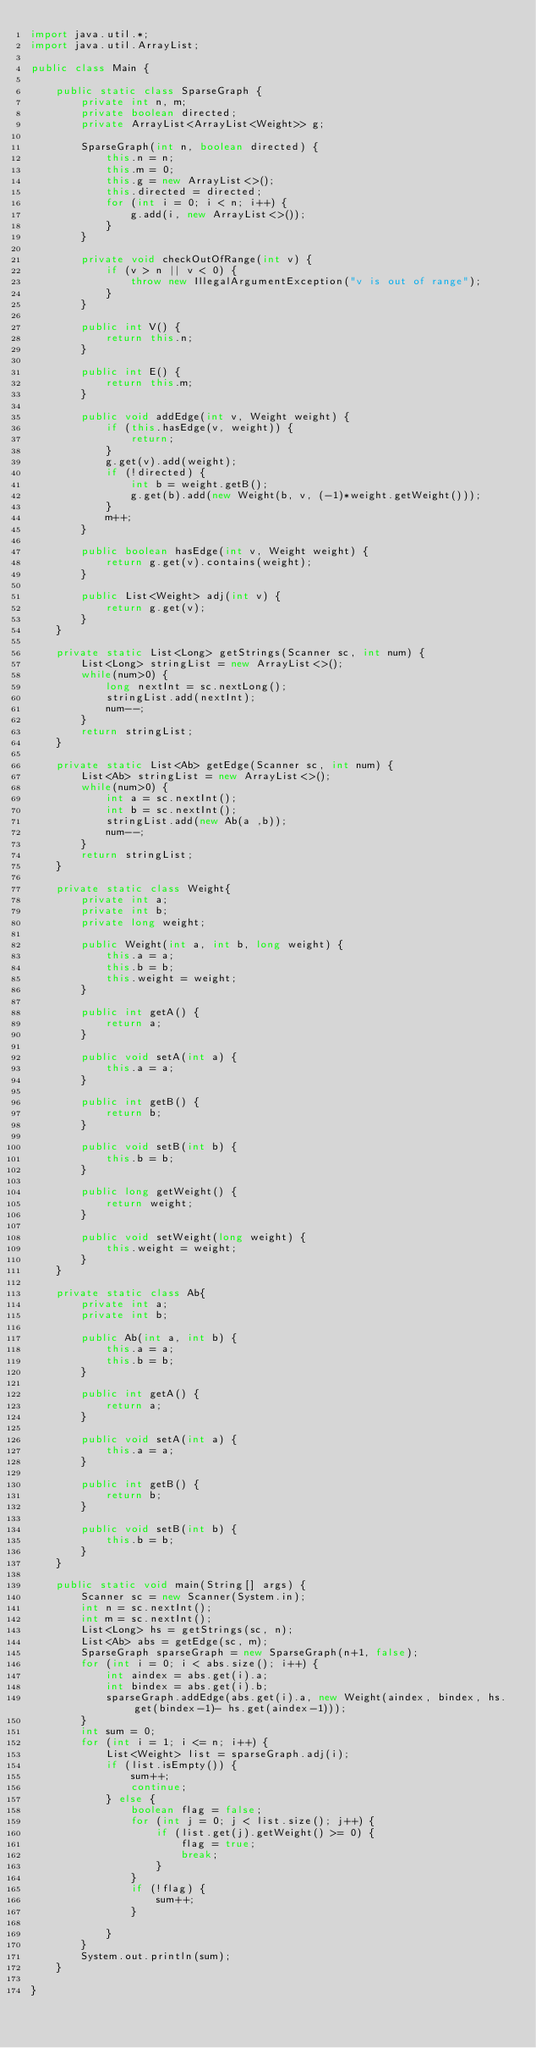<code> <loc_0><loc_0><loc_500><loc_500><_Java_>import java.util.*;
import java.util.ArrayList;

public class Main {

	public static class SparseGraph {
		private int n, m;
		private boolean directed;
		private ArrayList<ArrayList<Weight>> g;

		SparseGraph(int n, boolean directed) {
			this.n = n;
			this.m = 0;
			this.g = new ArrayList<>();
			this.directed = directed;
			for (int i = 0; i < n; i++) {
				g.add(i, new ArrayList<>());
			}
		}

		private void checkOutOfRange(int v) {
			if (v > n || v < 0) {
				throw new IllegalArgumentException("v is out of range");
			}
		}

		public int V() {
			return this.n;
		}

		public int E() {
			return this.m;
		}

		public void addEdge(int v, Weight weight) {
			if (this.hasEdge(v, weight)) {
				return;
			}
			g.get(v).add(weight);
			if (!directed) {
				int b = weight.getB();
				g.get(b).add(new Weight(b, v, (-1)*weight.getWeight()));
			}
			m++;
		}

		public boolean hasEdge(int v, Weight weight) {
			return g.get(v).contains(weight);
		}

		public List<Weight> adj(int v) {
			return g.get(v);
		}
	}

	private static List<Long> getStrings(Scanner sc, int num) {
		List<Long> stringList = new ArrayList<>();
		while(num>0) {
			long nextInt = sc.nextLong();
			stringList.add(nextInt);
			num--;
		}
		return stringList;
	}

	private static List<Ab> getEdge(Scanner sc, int num) {
		List<Ab> stringList = new ArrayList<>();
		while(num>0) {
			int a = sc.nextInt();
			int b = sc.nextInt();
			stringList.add(new Ab(a ,b));
			num--;
		}
		return stringList;
	}

	private static class Weight{
		private int a;
		private int b;
		private long weight;

		public Weight(int a, int b, long weight) {
			this.a = a;
			this.b = b;
			this.weight = weight;
		}

		public int getA() {
			return a;
		}

		public void setA(int a) {
			this.a = a;
		}

		public int getB() {
			return b;
		}

		public void setB(int b) {
			this.b = b;
		}

		public long getWeight() {
			return weight;
		}

		public void setWeight(long weight) {
			this.weight = weight;
		}
	}

	private static class Ab{
		private int a;
		private int b;

		public Ab(int a, int b) {
			this.a = a;
			this.b = b;
		}

		public int getA() {
			return a;
		}

		public void setA(int a) {
			this.a = a;
		}

		public int getB() {
			return b;
		}

		public void setB(int b) {
			this.b = b;
		}
	}

	public static void main(String[] args) {
		Scanner sc = new Scanner(System.in);
		int n = sc.nextInt();
		int m = sc.nextInt();
		List<Long> hs = getStrings(sc, n);
		List<Ab> abs = getEdge(sc, m);
		SparseGraph sparseGraph = new SparseGraph(n+1, false);
		for (int i = 0; i < abs.size(); i++) {
			int aindex = abs.get(i).a;
			int bindex = abs.get(i).b;
			sparseGraph.addEdge(abs.get(i).a, new Weight(aindex, bindex, hs.get(bindex-1)- hs.get(aindex-1)));
		}
		int sum = 0;
		for (int i = 1; i <= n; i++) {
			List<Weight> list = sparseGraph.adj(i);
			if (list.isEmpty()) {
				sum++;
				continue;
			} else {
				boolean flag = false;
				for (int j = 0; j < list.size(); j++) {
					if (list.get(j).getWeight() >= 0) {
						flag = true;
						break;
					}
				}
				if (!flag) {
					sum++;
				}

			}
		}
		System.out.println(sum);
	}

}
</code> 